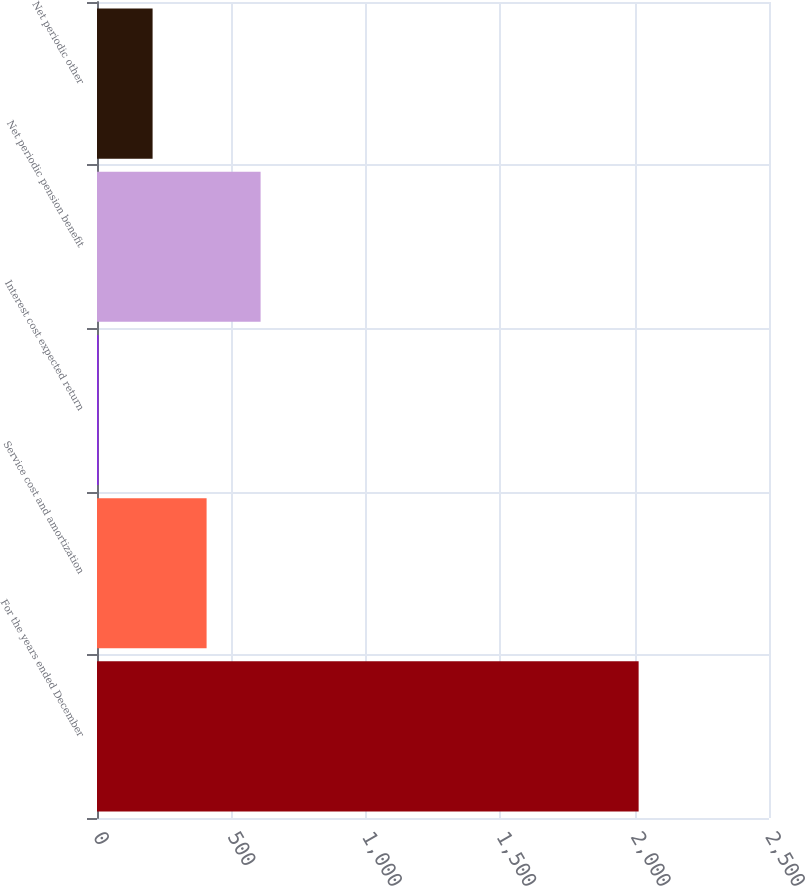Convert chart. <chart><loc_0><loc_0><loc_500><loc_500><bar_chart><fcel>For the years ended December<fcel>Service cost and amortization<fcel>Interest cost expected return<fcel>Net periodic pension benefit<fcel>Net periodic other<nl><fcel>2015<fcel>407.72<fcel>5.9<fcel>608.63<fcel>206.81<nl></chart> 